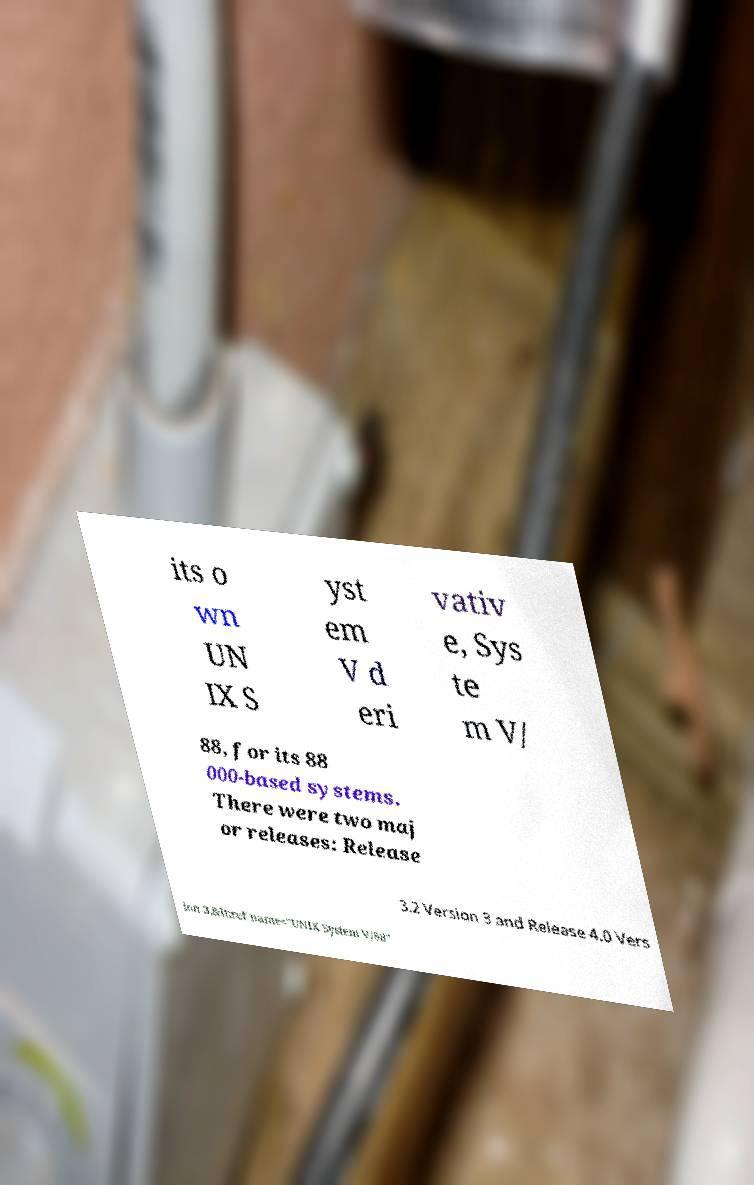Could you extract and type out the text from this image? its o wn UN IX S yst em V d eri vativ e, Sys te m V/ 88, for its 88 000-based systems. There were two maj or releases: Release 3.2 Version 3 and Release 4.0 Vers ion 3.&lt;ref name="UNIX System V/88" 